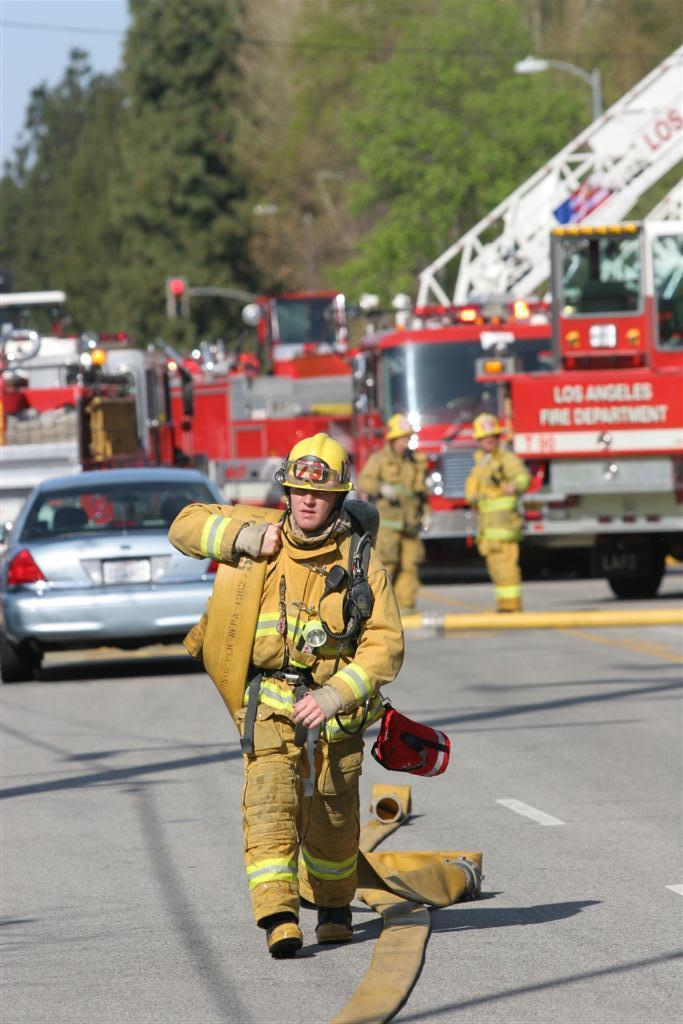<image>
Relay a brief, clear account of the picture shown. A fireman from Los Angeles walks down the road. 